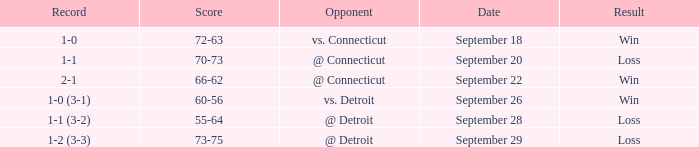WHAT IS THE SCORE WITH A RECORD OF 1-0? 72-63. 